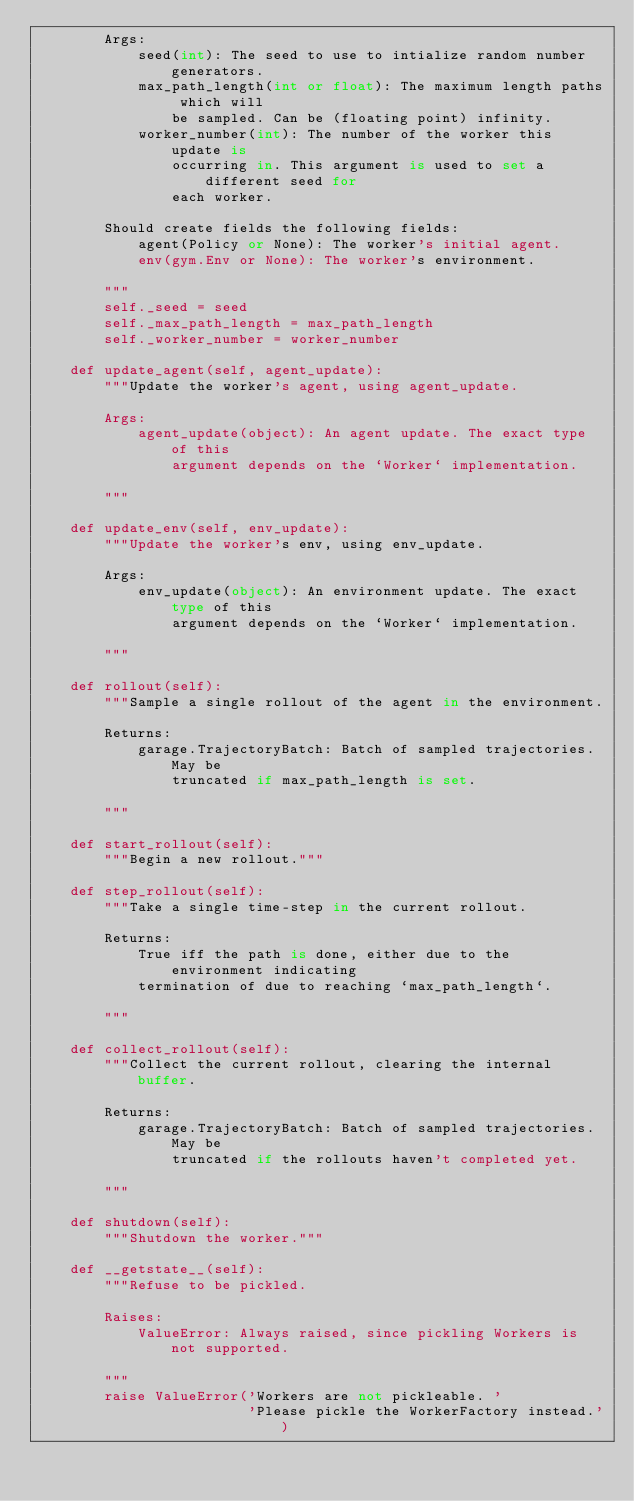<code> <loc_0><loc_0><loc_500><loc_500><_Python_>        Args:
            seed(int): The seed to use to intialize random number generators.
            max_path_length(int or float): The maximum length paths which will
                be sampled. Can be (floating point) infinity.
            worker_number(int): The number of the worker this update is
                occurring in. This argument is used to set a different seed for
                each worker.

        Should create fields the following fields:
            agent(Policy or None): The worker's initial agent.
            env(gym.Env or None): The worker's environment.

        """
        self._seed = seed
        self._max_path_length = max_path_length
        self._worker_number = worker_number

    def update_agent(self, agent_update):
        """Update the worker's agent, using agent_update.

        Args:
            agent_update(object): An agent update. The exact type of this
                argument depends on the `Worker` implementation.

        """

    def update_env(self, env_update):
        """Update the worker's env, using env_update.

        Args:
            env_update(object): An environment update. The exact type of this
                argument depends on the `Worker` implementation.

        """

    def rollout(self):
        """Sample a single rollout of the agent in the environment.

        Returns:
            garage.TrajectoryBatch: Batch of sampled trajectories. May be
                truncated if max_path_length is set.

        """

    def start_rollout(self):
        """Begin a new rollout."""

    def step_rollout(self):
        """Take a single time-step in the current rollout.

        Returns:
            True iff the path is done, either due to the environment indicating
            termination of due to reaching `max_path_length`.

        """

    def collect_rollout(self):
        """Collect the current rollout, clearing the internal buffer.

        Returns:
            garage.TrajectoryBatch: Batch of sampled trajectories. May be
                truncated if the rollouts haven't completed yet.

        """

    def shutdown(self):
        """Shutdown the worker."""

    def __getstate__(self):
        """Refuse to be pickled.

        Raises:
            ValueError: Always raised, since pickling Workers is not supported.

        """
        raise ValueError('Workers are not pickleable. '
                         'Please pickle the WorkerFactory instead.')
</code> 